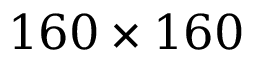<formula> <loc_0><loc_0><loc_500><loc_500>1 6 0 \times 1 6 0</formula> 